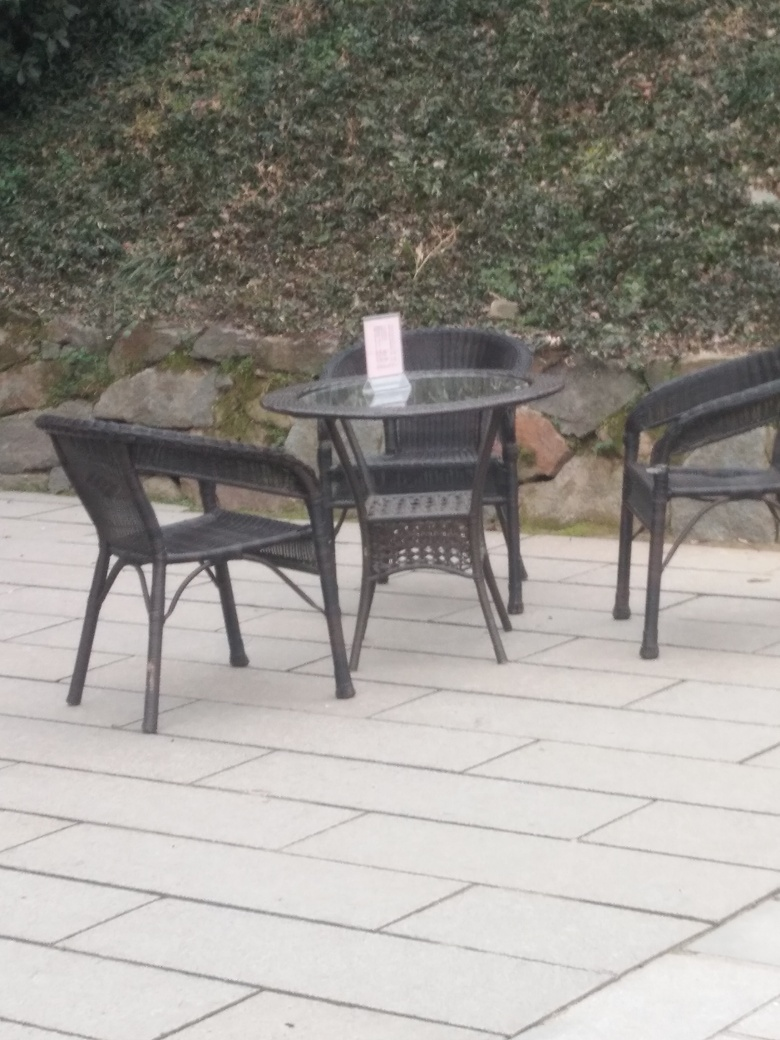What is the weather like in the scene depicted? The lighting in the image suggests an overcast sky, with diffuse natural light indicating that it may be a cool or cloudy day. There are no shadows that typically signify sunny weather, and the overall ambiance appears calm and slightly subdued. 